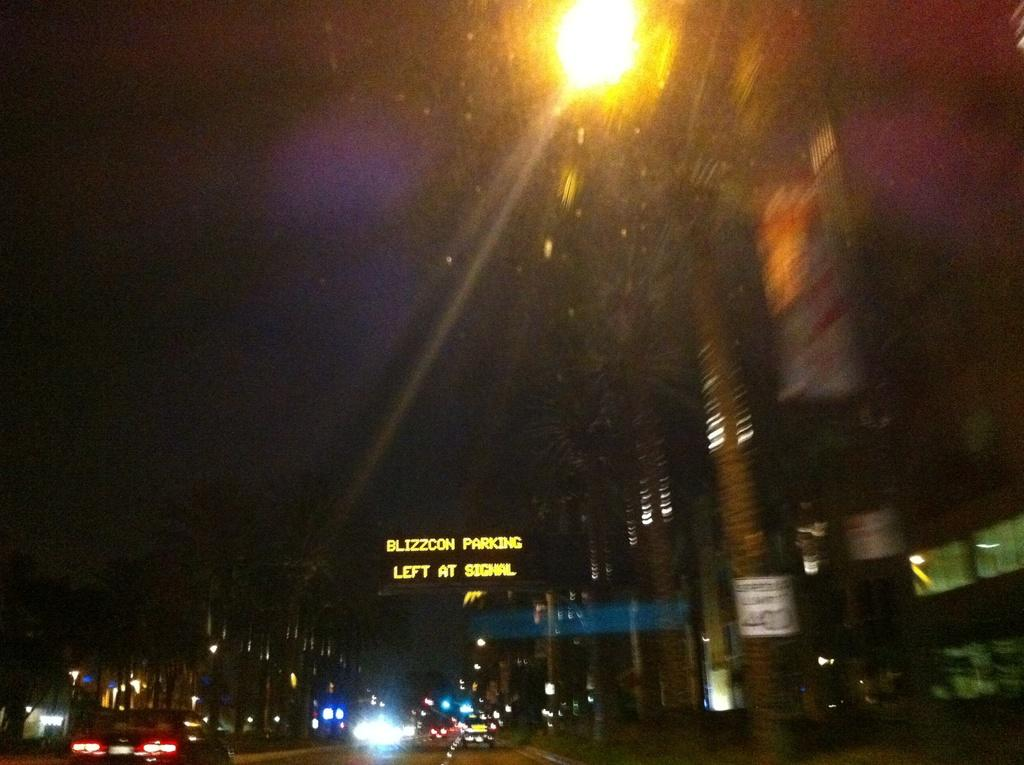What can be seen moving on the road in the image? There are vehicles on the road in the image. What type of light is visible in the image? There is a light visible in the image. What type of natural elements are present in the image? There are trees in the image. What type of man-made structure is present in the image? There is a building in the image. What type of sign or notice is present in the image? There is a board in the image. How would you describe the overall lighting condition in the image? The background of the image is dark. Can you see a crayon being used to draw on the vehicles in the image? There is no crayon present in the image. 